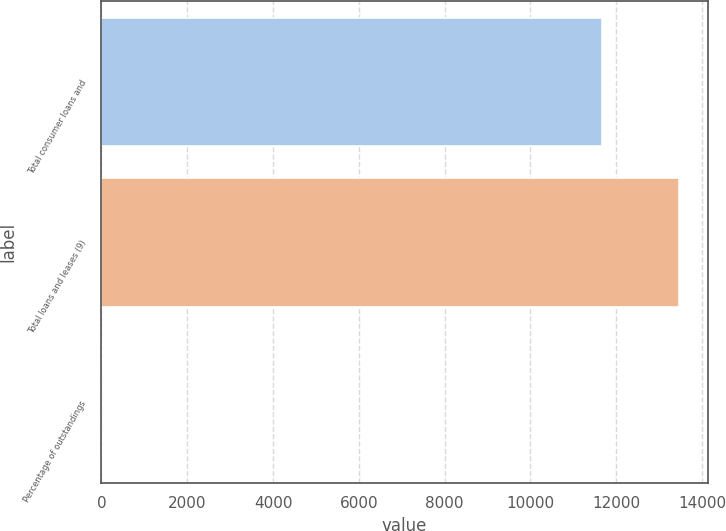<chart> <loc_0><loc_0><loc_500><loc_500><bar_chart><fcel>Total consumer loans and<fcel>Total loans and leases (9)<fcel>Percentage of outstandings<nl><fcel>11672<fcel>13463<fcel>1.44<nl></chart> 